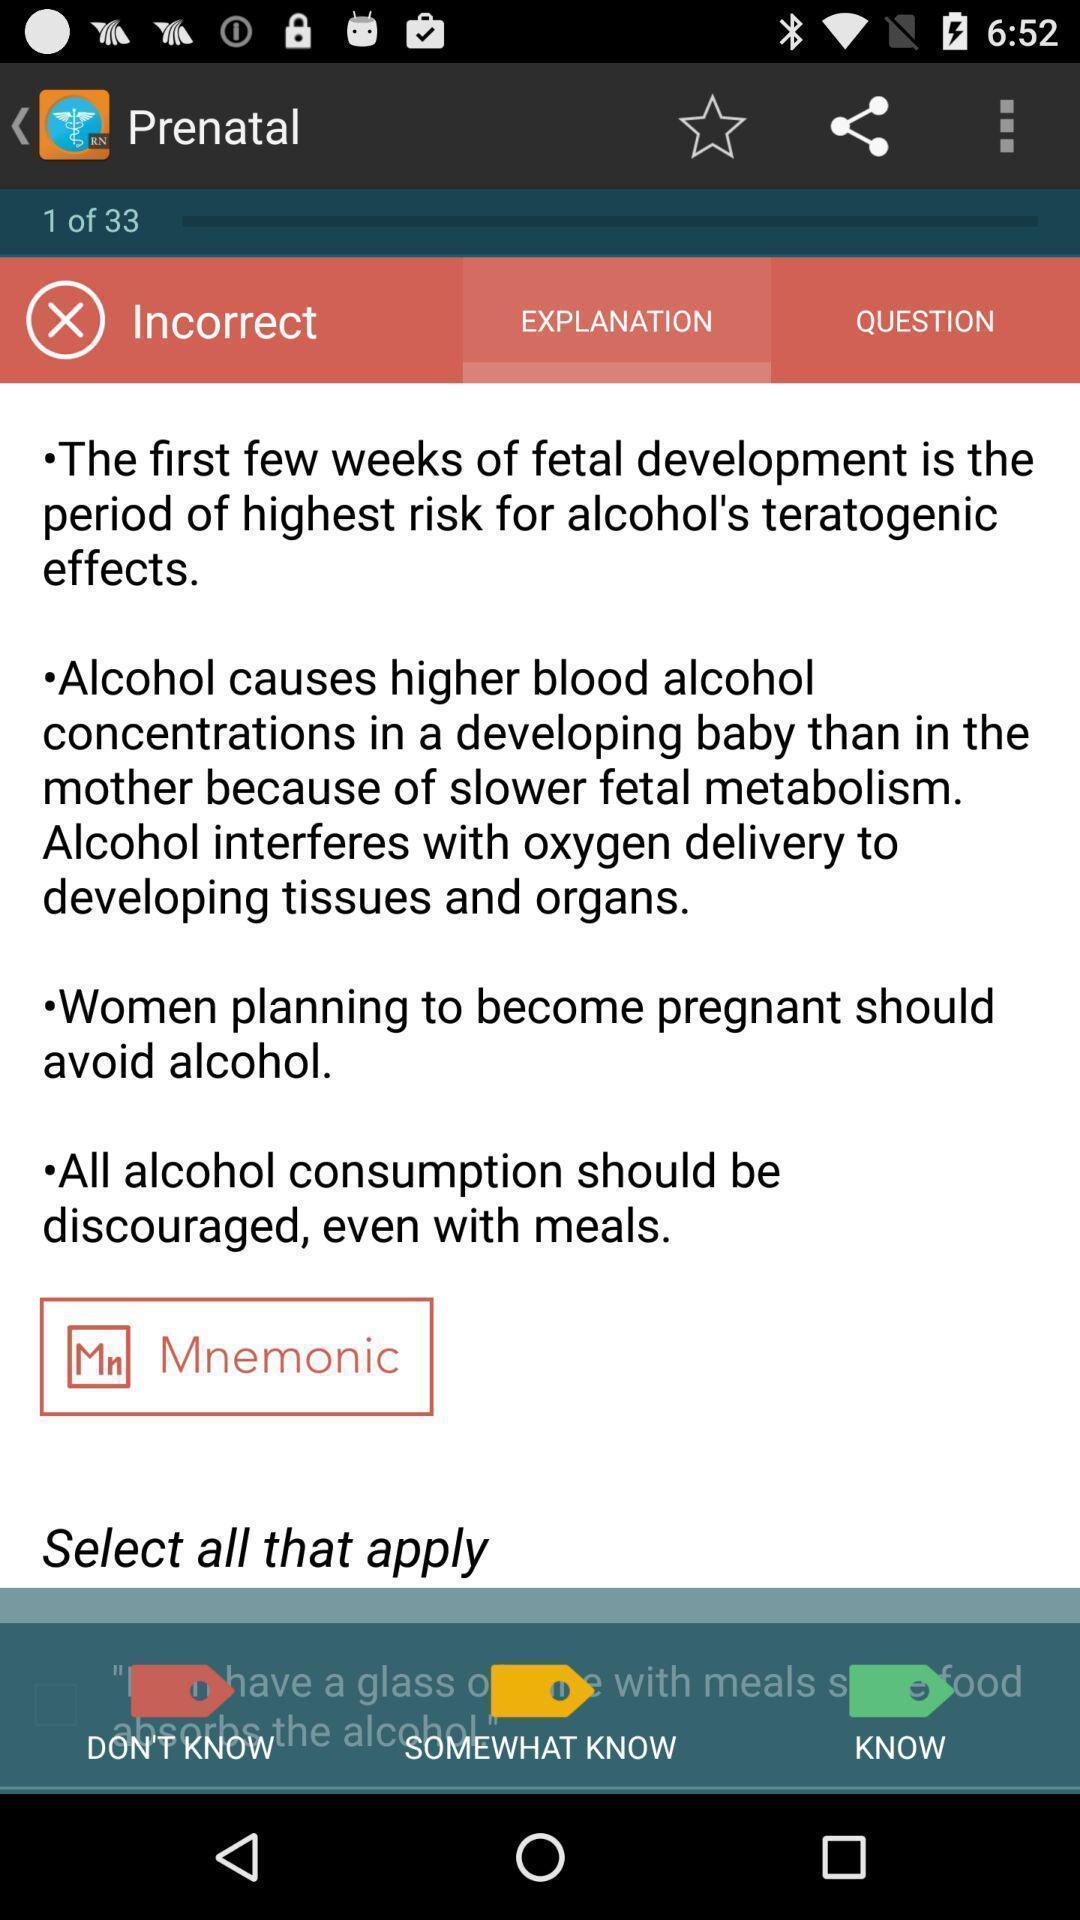Summarize the main components in this picture. Screen displaying the side effects of alcohol for pregnant woman. 